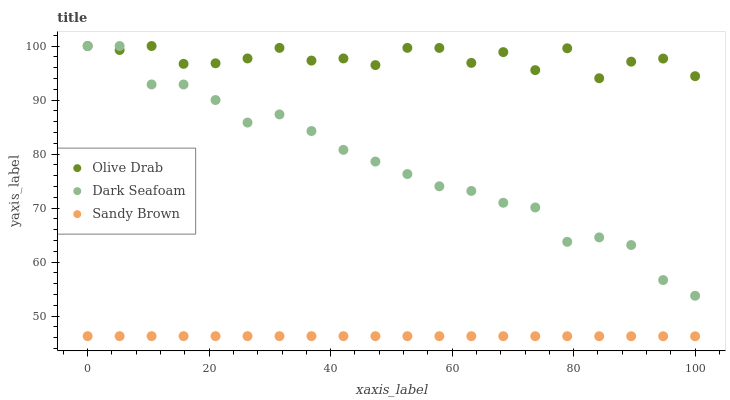Does Sandy Brown have the minimum area under the curve?
Answer yes or no. Yes. Does Olive Drab have the maximum area under the curve?
Answer yes or no. Yes. Does Olive Drab have the minimum area under the curve?
Answer yes or no. No. Does Sandy Brown have the maximum area under the curve?
Answer yes or no. No. Is Sandy Brown the smoothest?
Answer yes or no. Yes. Is Olive Drab the roughest?
Answer yes or no. Yes. Is Olive Drab the smoothest?
Answer yes or no. No. Is Sandy Brown the roughest?
Answer yes or no. No. Does Sandy Brown have the lowest value?
Answer yes or no. Yes. Does Olive Drab have the lowest value?
Answer yes or no. No. Does Olive Drab have the highest value?
Answer yes or no. Yes. Does Sandy Brown have the highest value?
Answer yes or no. No. Is Sandy Brown less than Olive Drab?
Answer yes or no. Yes. Is Olive Drab greater than Sandy Brown?
Answer yes or no. Yes. Does Dark Seafoam intersect Olive Drab?
Answer yes or no. Yes. Is Dark Seafoam less than Olive Drab?
Answer yes or no. No. Is Dark Seafoam greater than Olive Drab?
Answer yes or no. No. Does Sandy Brown intersect Olive Drab?
Answer yes or no. No. 